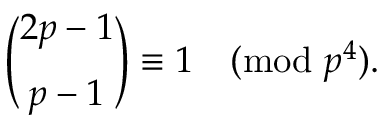Convert formula to latex. <formula><loc_0><loc_0><loc_500><loc_500>{ \binom { 2 p - 1 } { p - 1 } } \equiv 1 { \pmod { p ^ { 4 } } } .</formula> 